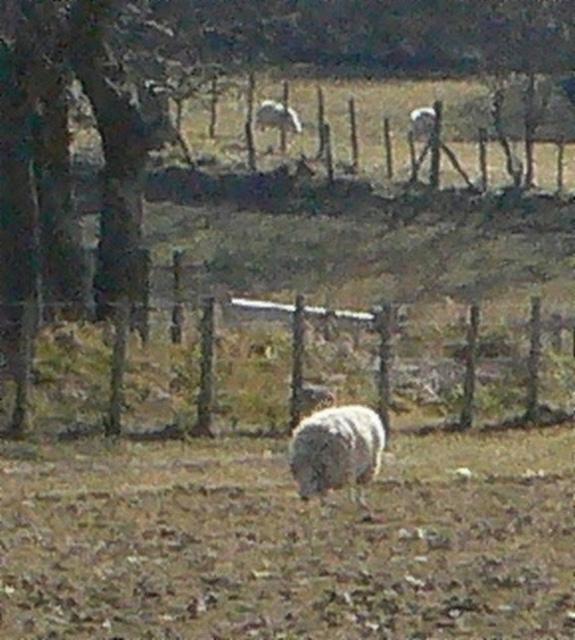Is that a chicken wire fence?
Concise answer only. Yes. What are the sheep standing on?
Quick response, please. Grass. Are these animals wild or domesticated?
Be succinct. Domesticated. What is the fence made from?
Keep it brief. Wood. How many sheep are in the back?
Answer briefly. 2. What is the fence made out of?
Be succinct. Wood. What is the wall made of?
Keep it brief. No wall. What is the most prominent color in the picture?
Write a very short answer. Brown. Has this sheep been sheared recently?
Give a very brief answer. No. Where are the animals standing?
Keep it brief. Field. What are these animals laying on?
Quick response, please. Grass. 